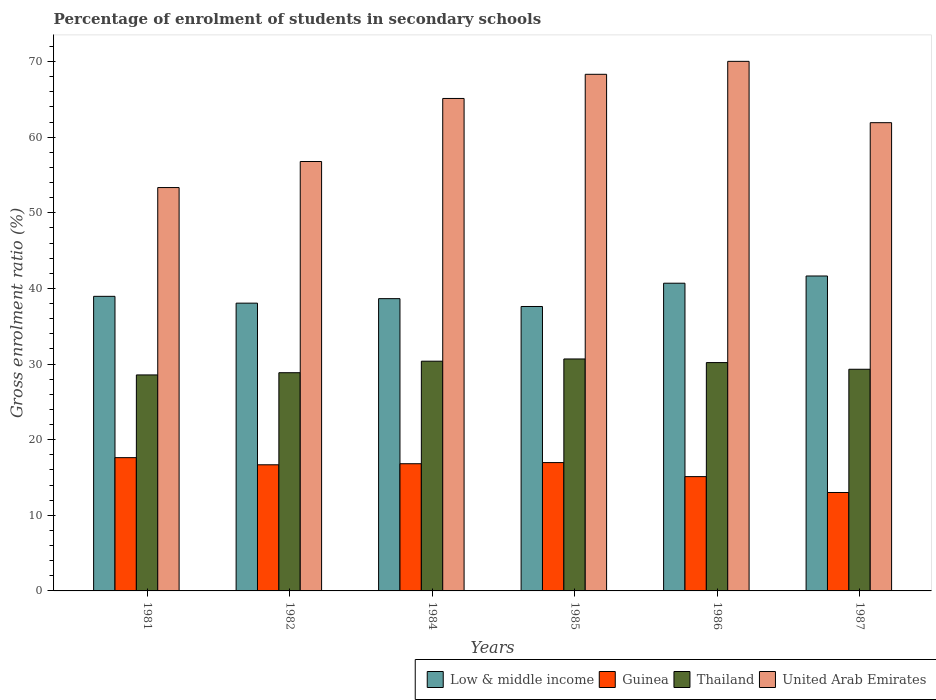How many different coloured bars are there?
Provide a succinct answer. 4. How many groups of bars are there?
Provide a succinct answer. 6. How many bars are there on the 5th tick from the right?
Your response must be concise. 4. What is the label of the 4th group of bars from the left?
Offer a very short reply. 1985. What is the percentage of students enrolled in secondary schools in United Arab Emirates in 1987?
Keep it short and to the point. 61.92. Across all years, what is the maximum percentage of students enrolled in secondary schools in United Arab Emirates?
Ensure brevity in your answer.  70.03. Across all years, what is the minimum percentage of students enrolled in secondary schools in Thailand?
Provide a short and direct response. 28.56. What is the total percentage of students enrolled in secondary schools in United Arab Emirates in the graph?
Provide a succinct answer. 375.5. What is the difference between the percentage of students enrolled in secondary schools in Guinea in 1981 and that in 1985?
Keep it short and to the point. 0.65. What is the difference between the percentage of students enrolled in secondary schools in Thailand in 1981 and the percentage of students enrolled in secondary schools in Low & middle income in 1982?
Your answer should be compact. -9.49. What is the average percentage of students enrolled in secondary schools in Thailand per year?
Your answer should be compact. 29.66. In the year 1984, what is the difference between the percentage of students enrolled in secondary schools in Low & middle income and percentage of students enrolled in secondary schools in United Arab Emirates?
Provide a short and direct response. -26.47. What is the ratio of the percentage of students enrolled in secondary schools in United Arab Emirates in 1982 to that in 1984?
Provide a short and direct response. 0.87. Is the percentage of students enrolled in secondary schools in Low & middle income in 1982 less than that in 1984?
Provide a succinct answer. Yes. Is the difference between the percentage of students enrolled in secondary schools in Low & middle income in 1981 and 1984 greater than the difference between the percentage of students enrolled in secondary schools in United Arab Emirates in 1981 and 1984?
Your answer should be compact. Yes. What is the difference between the highest and the second highest percentage of students enrolled in secondary schools in Guinea?
Provide a succinct answer. 0.65. What is the difference between the highest and the lowest percentage of students enrolled in secondary schools in Guinea?
Offer a terse response. 4.61. In how many years, is the percentage of students enrolled in secondary schools in United Arab Emirates greater than the average percentage of students enrolled in secondary schools in United Arab Emirates taken over all years?
Your answer should be very brief. 3. Is the sum of the percentage of students enrolled in secondary schools in Guinea in 1982 and 1986 greater than the maximum percentage of students enrolled in secondary schools in United Arab Emirates across all years?
Your response must be concise. No. What does the 3rd bar from the right in 1984 represents?
Your answer should be compact. Guinea. How many bars are there?
Your answer should be compact. 24. Are all the bars in the graph horizontal?
Your answer should be compact. No. How many years are there in the graph?
Provide a succinct answer. 6. Are the values on the major ticks of Y-axis written in scientific E-notation?
Ensure brevity in your answer.  No. Where does the legend appear in the graph?
Offer a terse response. Bottom right. How are the legend labels stacked?
Offer a terse response. Horizontal. What is the title of the graph?
Your answer should be very brief. Percentage of enrolment of students in secondary schools. What is the label or title of the X-axis?
Offer a terse response. Years. What is the Gross enrolment ratio (%) in Low & middle income in 1981?
Provide a succinct answer. 38.95. What is the Gross enrolment ratio (%) of Guinea in 1981?
Offer a very short reply. 17.62. What is the Gross enrolment ratio (%) of Thailand in 1981?
Your response must be concise. 28.56. What is the Gross enrolment ratio (%) in United Arab Emirates in 1981?
Make the answer very short. 53.34. What is the Gross enrolment ratio (%) in Low & middle income in 1982?
Provide a succinct answer. 38.05. What is the Gross enrolment ratio (%) of Guinea in 1982?
Give a very brief answer. 16.68. What is the Gross enrolment ratio (%) in Thailand in 1982?
Give a very brief answer. 28.85. What is the Gross enrolment ratio (%) of United Arab Emirates in 1982?
Offer a terse response. 56.78. What is the Gross enrolment ratio (%) of Low & middle income in 1984?
Offer a terse response. 38.65. What is the Gross enrolment ratio (%) of Guinea in 1984?
Make the answer very short. 16.82. What is the Gross enrolment ratio (%) in Thailand in 1984?
Your response must be concise. 30.38. What is the Gross enrolment ratio (%) in United Arab Emirates in 1984?
Provide a short and direct response. 65.12. What is the Gross enrolment ratio (%) of Low & middle income in 1985?
Ensure brevity in your answer.  37.61. What is the Gross enrolment ratio (%) of Guinea in 1985?
Your answer should be very brief. 16.97. What is the Gross enrolment ratio (%) in Thailand in 1985?
Ensure brevity in your answer.  30.67. What is the Gross enrolment ratio (%) of United Arab Emirates in 1985?
Ensure brevity in your answer.  68.31. What is the Gross enrolment ratio (%) of Low & middle income in 1986?
Make the answer very short. 40.69. What is the Gross enrolment ratio (%) in Guinea in 1986?
Offer a very short reply. 15.12. What is the Gross enrolment ratio (%) in Thailand in 1986?
Offer a very short reply. 30.19. What is the Gross enrolment ratio (%) in United Arab Emirates in 1986?
Offer a very short reply. 70.03. What is the Gross enrolment ratio (%) in Low & middle income in 1987?
Provide a short and direct response. 41.64. What is the Gross enrolment ratio (%) in Guinea in 1987?
Ensure brevity in your answer.  13.02. What is the Gross enrolment ratio (%) in Thailand in 1987?
Offer a terse response. 29.31. What is the Gross enrolment ratio (%) in United Arab Emirates in 1987?
Your response must be concise. 61.92. Across all years, what is the maximum Gross enrolment ratio (%) of Low & middle income?
Provide a succinct answer. 41.64. Across all years, what is the maximum Gross enrolment ratio (%) of Guinea?
Your answer should be very brief. 17.62. Across all years, what is the maximum Gross enrolment ratio (%) in Thailand?
Offer a very short reply. 30.67. Across all years, what is the maximum Gross enrolment ratio (%) in United Arab Emirates?
Your response must be concise. 70.03. Across all years, what is the minimum Gross enrolment ratio (%) in Low & middle income?
Ensure brevity in your answer.  37.61. Across all years, what is the minimum Gross enrolment ratio (%) in Guinea?
Give a very brief answer. 13.02. Across all years, what is the minimum Gross enrolment ratio (%) of Thailand?
Your response must be concise. 28.56. Across all years, what is the minimum Gross enrolment ratio (%) of United Arab Emirates?
Give a very brief answer. 53.34. What is the total Gross enrolment ratio (%) of Low & middle income in the graph?
Your answer should be very brief. 235.6. What is the total Gross enrolment ratio (%) in Guinea in the graph?
Ensure brevity in your answer.  96.22. What is the total Gross enrolment ratio (%) of Thailand in the graph?
Make the answer very short. 177.97. What is the total Gross enrolment ratio (%) of United Arab Emirates in the graph?
Provide a short and direct response. 375.5. What is the difference between the Gross enrolment ratio (%) in Low & middle income in 1981 and that in 1982?
Your answer should be compact. 0.9. What is the difference between the Gross enrolment ratio (%) in Guinea in 1981 and that in 1982?
Provide a short and direct response. 0.94. What is the difference between the Gross enrolment ratio (%) in Thailand in 1981 and that in 1982?
Offer a terse response. -0.29. What is the difference between the Gross enrolment ratio (%) of United Arab Emirates in 1981 and that in 1982?
Keep it short and to the point. -3.44. What is the difference between the Gross enrolment ratio (%) of Low & middle income in 1981 and that in 1984?
Make the answer very short. 0.31. What is the difference between the Gross enrolment ratio (%) of Guinea in 1981 and that in 1984?
Your response must be concise. 0.8. What is the difference between the Gross enrolment ratio (%) in Thailand in 1981 and that in 1984?
Your answer should be very brief. -1.82. What is the difference between the Gross enrolment ratio (%) in United Arab Emirates in 1981 and that in 1984?
Provide a short and direct response. -11.78. What is the difference between the Gross enrolment ratio (%) in Low & middle income in 1981 and that in 1985?
Make the answer very short. 1.34. What is the difference between the Gross enrolment ratio (%) in Guinea in 1981 and that in 1985?
Your response must be concise. 0.65. What is the difference between the Gross enrolment ratio (%) of Thailand in 1981 and that in 1985?
Provide a short and direct response. -2.11. What is the difference between the Gross enrolment ratio (%) of United Arab Emirates in 1981 and that in 1985?
Your response must be concise. -14.97. What is the difference between the Gross enrolment ratio (%) in Low & middle income in 1981 and that in 1986?
Make the answer very short. -1.74. What is the difference between the Gross enrolment ratio (%) of Guinea in 1981 and that in 1986?
Ensure brevity in your answer.  2.51. What is the difference between the Gross enrolment ratio (%) in Thailand in 1981 and that in 1986?
Give a very brief answer. -1.63. What is the difference between the Gross enrolment ratio (%) of United Arab Emirates in 1981 and that in 1986?
Your answer should be compact. -16.69. What is the difference between the Gross enrolment ratio (%) in Low & middle income in 1981 and that in 1987?
Make the answer very short. -2.69. What is the difference between the Gross enrolment ratio (%) of Guinea in 1981 and that in 1987?
Your answer should be very brief. 4.61. What is the difference between the Gross enrolment ratio (%) of Thailand in 1981 and that in 1987?
Provide a short and direct response. -0.75. What is the difference between the Gross enrolment ratio (%) of United Arab Emirates in 1981 and that in 1987?
Ensure brevity in your answer.  -8.58. What is the difference between the Gross enrolment ratio (%) of Low & middle income in 1982 and that in 1984?
Offer a very short reply. -0.6. What is the difference between the Gross enrolment ratio (%) of Guinea in 1982 and that in 1984?
Make the answer very short. -0.14. What is the difference between the Gross enrolment ratio (%) in Thailand in 1982 and that in 1984?
Provide a short and direct response. -1.52. What is the difference between the Gross enrolment ratio (%) in United Arab Emirates in 1982 and that in 1984?
Your response must be concise. -8.34. What is the difference between the Gross enrolment ratio (%) in Low & middle income in 1982 and that in 1985?
Make the answer very short. 0.44. What is the difference between the Gross enrolment ratio (%) in Guinea in 1982 and that in 1985?
Ensure brevity in your answer.  -0.29. What is the difference between the Gross enrolment ratio (%) in Thailand in 1982 and that in 1985?
Make the answer very short. -1.82. What is the difference between the Gross enrolment ratio (%) in United Arab Emirates in 1982 and that in 1985?
Your answer should be very brief. -11.53. What is the difference between the Gross enrolment ratio (%) of Low & middle income in 1982 and that in 1986?
Offer a terse response. -2.64. What is the difference between the Gross enrolment ratio (%) of Guinea in 1982 and that in 1986?
Provide a short and direct response. 1.56. What is the difference between the Gross enrolment ratio (%) in Thailand in 1982 and that in 1986?
Offer a very short reply. -1.34. What is the difference between the Gross enrolment ratio (%) of United Arab Emirates in 1982 and that in 1986?
Make the answer very short. -13.24. What is the difference between the Gross enrolment ratio (%) in Low & middle income in 1982 and that in 1987?
Provide a short and direct response. -3.59. What is the difference between the Gross enrolment ratio (%) of Guinea in 1982 and that in 1987?
Keep it short and to the point. 3.66. What is the difference between the Gross enrolment ratio (%) in Thailand in 1982 and that in 1987?
Your answer should be compact. -0.46. What is the difference between the Gross enrolment ratio (%) in United Arab Emirates in 1982 and that in 1987?
Your response must be concise. -5.13. What is the difference between the Gross enrolment ratio (%) in Low & middle income in 1984 and that in 1985?
Your answer should be compact. 1.04. What is the difference between the Gross enrolment ratio (%) in Guinea in 1984 and that in 1985?
Offer a very short reply. -0.15. What is the difference between the Gross enrolment ratio (%) of Thailand in 1984 and that in 1985?
Provide a short and direct response. -0.29. What is the difference between the Gross enrolment ratio (%) in United Arab Emirates in 1984 and that in 1985?
Your answer should be very brief. -3.19. What is the difference between the Gross enrolment ratio (%) of Low & middle income in 1984 and that in 1986?
Make the answer very short. -2.04. What is the difference between the Gross enrolment ratio (%) of Guinea in 1984 and that in 1986?
Provide a succinct answer. 1.7. What is the difference between the Gross enrolment ratio (%) in Thailand in 1984 and that in 1986?
Make the answer very short. 0.18. What is the difference between the Gross enrolment ratio (%) in United Arab Emirates in 1984 and that in 1986?
Your answer should be compact. -4.91. What is the difference between the Gross enrolment ratio (%) of Low & middle income in 1984 and that in 1987?
Offer a terse response. -3. What is the difference between the Gross enrolment ratio (%) of Guinea in 1984 and that in 1987?
Your response must be concise. 3.8. What is the difference between the Gross enrolment ratio (%) of Thailand in 1984 and that in 1987?
Provide a short and direct response. 1.07. What is the difference between the Gross enrolment ratio (%) in United Arab Emirates in 1984 and that in 1987?
Offer a very short reply. 3.2. What is the difference between the Gross enrolment ratio (%) of Low & middle income in 1985 and that in 1986?
Keep it short and to the point. -3.08. What is the difference between the Gross enrolment ratio (%) in Guinea in 1985 and that in 1986?
Provide a succinct answer. 1.85. What is the difference between the Gross enrolment ratio (%) in Thailand in 1985 and that in 1986?
Your answer should be very brief. 0.48. What is the difference between the Gross enrolment ratio (%) of United Arab Emirates in 1985 and that in 1986?
Provide a short and direct response. -1.71. What is the difference between the Gross enrolment ratio (%) of Low & middle income in 1985 and that in 1987?
Give a very brief answer. -4.03. What is the difference between the Gross enrolment ratio (%) of Guinea in 1985 and that in 1987?
Keep it short and to the point. 3.95. What is the difference between the Gross enrolment ratio (%) of Thailand in 1985 and that in 1987?
Offer a terse response. 1.36. What is the difference between the Gross enrolment ratio (%) in United Arab Emirates in 1985 and that in 1987?
Your response must be concise. 6.4. What is the difference between the Gross enrolment ratio (%) of Low & middle income in 1986 and that in 1987?
Offer a terse response. -0.95. What is the difference between the Gross enrolment ratio (%) in Guinea in 1986 and that in 1987?
Keep it short and to the point. 2.1. What is the difference between the Gross enrolment ratio (%) in Thailand in 1986 and that in 1987?
Keep it short and to the point. 0.88. What is the difference between the Gross enrolment ratio (%) of United Arab Emirates in 1986 and that in 1987?
Provide a succinct answer. 8.11. What is the difference between the Gross enrolment ratio (%) in Low & middle income in 1981 and the Gross enrolment ratio (%) in Guinea in 1982?
Make the answer very short. 22.28. What is the difference between the Gross enrolment ratio (%) in Low & middle income in 1981 and the Gross enrolment ratio (%) in Thailand in 1982?
Ensure brevity in your answer.  10.1. What is the difference between the Gross enrolment ratio (%) in Low & middle income in 1981 and the Gross enrolment ratio (%) in United Arab Emirates in 1982?
Offer a terse response. -17.83. What is the difference between the Gross enrolment ratio (%) in Guinea in 1981 and the Gross enrolment ratio (%) in Thailand in 1982?
Provide a succinct answer. -11.23. What is the difference between the Gross enrolment ratio (%) of Guinea in 1981 and the Gross enrolment ratio (%) of United Arab Emirates in 1982?
Give a very brief answer. -39.16. What is the difference between the Gross enrolment ratio (%) in Thailand in 1981 and the Gross enrolment ratio (%) in United Arab Emirates in 1982?
Your answer should be very brief. -28.22. What is the difference between the Gross enrolment ratio (%) of Low & middle income in 1981 and the Gross enrolment ratio (%) of Guinea in 1984?
Your answer should be very brief. 22.13. What is the difference between the Gross enrolment ratio (%) of Low & middle income in 1981 and the Gross enrolment ratio (%) of Thailand in 1984?
Give a very brief answer. 8.58. What is the difference between the Gross enrolment ratio (%) of Low & middle income in 1981 and the Gross enrolment ratio (%) of United Arab Emirates in 1984?
Your answer should be compact. -26.17. What is the difference between the Gross enrolment ratio (%) of Guinea in 1981 and the Gross enrolment ratio (%) of Thailand in 1984?
Give a very brief answer. -12.76. What is the difference between the Gross enrolment ratio (%) in Guinea in 1981 and the Gross enrolment ratio (%) in United Arab Emirates in 1984?
Provide a short and direct response. -47.5. What is the difference between the Gross enrolment ratio (%) in Thailand in 1981 and the Gross enrolment ratio (%) in United Arab Emirates in 1984?
Provide a short and direct response. -36.56. What is the difference between the Gross enrolment ratio (%) in Low & middle income in 1981 and the Gross enrolment ratio (%) in Guinea in 1985?
Provide a short and direct response. 21.98. What is the difference between the Gross enrolment ratio (%) in Low & middle income in 1981 and the Gross enrolment ratio (%) in Thailand in 1985?
Provide a succinct answer. 8.28. What is the difference between the Gross enrolment ratio (%) of Low & middle income in 1981 and the Gross enrolment ratio (%) of United Arab Emirates in 1985?
Keep it short and to the point. -29.36. What is the difference between the Gross enrolment ratio (%) in Guinea in 1981 and the Gross enrolment ratio (%) in Thailand in 1985?
Your response must be concise. -13.05. What is the difference between the Gross enrolment ratio (%) in Guinea in 1981 and the Gross enrolment ratio (%) in United Arab Emirates in 1985?
Provide a short and direct response. -50.69. What is the difference between the Gross enrolment ratio (%) in Thailand in 1981 and the Gross enrolment ratio (%) in United Arab Emirates in 1985?
Your answer should be compact. -39.75. What is the difference between the Gross enrolment ratio (%) of Low & middle income in 1981 and the Gross enrolment ratio (%) of Guinea in 1986?
Your answer should be very brief. 23.84. What is the difference between the Gross enrolment ratio (%) of Low & middle income in 1981 and the Gross enrolment ratio (%) of Thailand in 1986?
Provide a succinct answer. 8.76. What is the difference between the Gross enrolment ratio (%) of Low & middle income in 1981 and the Gross enrolment ratio (%) of United Arab Emirates in 1986?
Provide a succinct answer. -31.07. What is the difference between the Gross enrolment ratio (%) in Guinea in 1981 and the Gross enrolment ratio (%) in Thailand in 1986?
Give a very brief answer. -12.57. What is the difference between the Gross enrolment ratio (%) of Guinea in 1981 and the Gross enrolment ratio (%) of United Arab Emirates in 1986?
Make the answer very short. -52.4. What is the difference between the Gross enrolment ratio (%) of Thailand in 1981 and the Gross enrolment ratio (%) of United Arab Emirates in 1986?
Your response must be concise. -41.46. What is the difference between the Gross enrolment ratio (%) in Low & middle income in 1981 and the Gross enrolment ratio (%) in Guinea in 1987?
Give a very brief answer. 25.94. What is the difference between the Gross enrolment ratio (%) of Low & middle income in 1981 and the Gross enrolment ratio (%) of Thailand in 1987?
Offer a terse response. 9.64. What is the difference between the Gross enrolment ratio (%) in Low & middle income in 1981 and the Gross enrolment ratio (%) in United Arab Emirates in 1987?
Offer a terse response. -22.96. What is the difference between the Gross enrolment ratio (%) of Guinea in 1981 and the Gross enrolment ratio (%) of Thailand in 1987?
Offer a very short reply. -11.69. What is the difference between the Gross enrolment ratio (%) of Guinea in 1981 and the Gross enrolment ratio (%) of United Arab Emirates in 1987?
Make the answer very short. -44.29. What is the difference between the Gross enrolment ratio (%) in Thailand in 1981 and the Gross enrolment ratio (%) in United Arab Emirates in 1987?
Your response must be concise. -33.35. What is the difference between the Gross enrolment ratio (%) of Low & middle income in 1982 and the Gross enrolment ratio (%) of Guinea in 1984?
Your response must be concise. 21.23. What is the difference between the Gross enrolment ratio (%) of Low & middle income in 1982 and the Gross enrolment ratio (%) of Thailand in 1984?
Your response must be concise. 7.67. What is the difference between the Gross enrolment ratio (%) in Low & middle income in 1982 and the Gross enrolment ratio (%) in United Arab Emirates in 1984?
Your response must be concise. -27.07. What is the difference between the Gross enrolment ratio (%) of Guinea in 1982 and the Gross enrolment ratio (%) of Thailand in 1984?
Your answer should be very brief. -13.7. What is the difference between the Gross enrolment ratio (%) of Guinea in 1982 and the Gross enrolment ratio (%) of United Arab Emirates in 1984?
Provide a succinct answer. -48.44. What is the difference between the Gross enrolment ratio (%) in Thailand in 1982 and the Gross enrolment ratio (%) in United Arab Emirates in 1984?
Offer a very short reply. -36.27. What is the difference between the Gross enrolment ratio (%) in Low & middle income in 1982 and the Gross enrolment ratio (%) in Guinea in 1985?
Your response must be concise. 21.08. What is the difference between the Gross enrolment ratio (%) of Low & middle income in 1982 and the Gross enrolment ratio (%) of Thailand in 1985?
Provide a succinct answer. 7.38. What is the difference between the Gross enrolment ratio (%) of Low & middle income in 1982 and the Gross enrolment ratio (%) of United Arab Emirates in 1985?
Offer a terse response. -30.26. What is the difference between the Gross enrolment ratio (%) of Guinea in 1982 and the Gross enrolment ratio (%) of Thailand in 1985?
Offer a terse response. -13.99. What is the difference between the Gross enrolment ratio (%) in Guinea in 1982 and the Gross enrolment ratio (%) in United Arab Emirates in 1985?
Keep it short and to the point. -51.63. What is the difference between the Gross enrolment ratio (%) of Thailand in 1982 and the Gross enrolment ratio (%) of United Arab Emirates in 1985?
Offer a terse response. -39.46. What is the difference between the Gross enrolment ratio (%) of Low & middle income in 1982 and the Gross enrolment ratio (%) of Guinea in 1986?
Provide a succinct answer. 22.94. What is the difference between the Gross enrolment ratio (%) in Low & middle income in 1982 and the Gross enrolment ratio (%) in Thailand in 1986?
Provide a succinct answer. 7.86. What is the difference between the Gross enrolment ratio (%) of Low & middle income in 1982 and the Gross enrolment ratio (%) of United Arab Emirates in 1986?
Offer a terse response. -31.97. What is the difference between the Gross enrolment ratio (%) of Guinea in 1982 and the Gross enrolment ratio (%) of Thailand in 1986?
Make the answer very short. -13.51. What is the difference between the Gross enrolment ratio (%) in Guinea in 1982 and the Gross enrolment ratio (%) in United Arab Emirates in 1986?
Offer a terse response. -53.35. What is the difference between the Gross enrolment ratio (%) in Thailand in 1982 and the Gross enrolment ratio (%) in United Arab Emirates in 1986?
Your answer should be compact. -41.17. What is the difference between the Gross enrolment ratio (%) of Low & middle income in 1982 and the Gross enrolment ratio (%) of Guinea in 1987?
Make the answer very short. 25.04. What is the difference between the Gross enrolment ratio (%) in Low & middle income in 1982 and the Gross enrolment ratio (%) in Thailand in 1987?
Keep it short and to the point. 8.74. What is the difference between the Gross enrolment ratio (%) in Low & middle income in 1982 and the Gross enrolment ratio (%) in United Arab Emirates in 1987?
Make the answer very short. -23.86. What is the difference between the Gross enrolment ratio (%) in Guinea in 1982 and the Gross enrolment ratio (%) in Thailand in 1987?
Provide a succinct answer. -12.63. What is the difference between the Gross enrolment ratio (%) of Guinea in 1982 and the Gross enrolment ratio (%) of United Arab Emirates in 1987?
Keep it short and to the point. -45.24. What is the difference between the Gross enrolment ratio (%) in Thailand in 1982 and the Gross enrolment ratio (%) in United Arab Emirates in 1987?
Provide a succinct answer. -33.06. What is the difference between the Gross enrolment ratio (%) of Low & middle income in 1984 and the Gross enrolment ratio (%) of Guinea in 1985?
Keep it short and to the point. 21.68. What is the difference between the Gross enrolment ratio (%) of Low & middle income in 1984 and the Gross enrolment ratio (%) of Thailand in 1985?
Offer a terse response. 7.98. What is the difference between the Gross enrolment ratio (%) of Low & middle income in 1984 and the Gross enrolment ratio (%) of United Arab Emirates in 1985?
Your response must be concise. -29.67. What is the difference between the Gross enrolment ratio (%) of Guinea in 1984 and the Gross enrolment ratio (%) of Thailand in 1985?
Ensure brevity in your answer.  -13.85. What is the difference between the Gross enrolment ratio (%) in Guinea in 1984 and the Gross enrolment ratio (%) in United Arab Emirates in 1985?
Keep it short and to the point. -51.49. What is the difference between the Gross enrolment ratio (%) in Thailand in 1984 and the Gross enrolment ratio (%) in United Arab Emirates in 1985?
Provide a succinct answer. -37.94. What is the difference between the Gross enrolment ratio (%) of Low & middle income in 1984 and the Gross enrolment ratio (%) of Guinea in 1986?
Ensure brevity in your answer.  23.53. What is the difference between the Gross enrolment ratio (%) of Low & middle income in 1984 and the Gross enrolment ratio (%) of Thailand in 1986?
Ensure brevity in your answer.  8.45. What is the difference between the Gross enrolment ratio (%) of Low & middle income in 1984 and the Gross enrolment ratio (%) of United Arab Emirates in 1986?
Your response must be concise. -31.38. What is the difference between the Gross enrolment ratio (%) of Guinea in 1984 and the Gross enrolment ratio (%) of Thailand in 1986?
Ensure brevity in your answer.  -13.37. What is the difference between the Gross enrolment ratio (%) of Guinea in 1984 and the Gross enrolment ratio (%) of United Arab Emirates in 1986?
Provide a short and direct response. -53.21. What is the difference between the Gross enrolment ratio (%) in Thailand in 1984 and the Gross enrolment ratio (%) in United Arab Emirates in 1986?
Your response must be concise. -39.65. What is the difference between the Gross enrolment ratio (%) in Low & middle income in 1984 and the Gross enrolment ratio (%) in Guinea in 1987?
Offer a very short reply. 25.63. What is the difference between the Gross enrolment ratio (%) of Low & middle income in 1984 and the Gross enrolment ratio (%) of Thailand in 1987?
Your answer should be compact. 9.34. What is the difference between the Gross enrolment ratio (%) in Low & middle income in 1984 and the Gross enrolment ratio (%) in United Arab Emirates in 1987?
Your answer should be very brief. -23.27. What is the difference between the Gross enrolment ratio (%) of Guinea in 1984 and the Gross enrolment ratio (%) of Thailand in 1987?
Offer a very short reply. -12.49. What is the difference between the Gross enrolment ratio (%) in Guinea in 1984 and the Gross enrolment ratio (%) in United Arab Emirates in 1987?
Provide a succinct answer. -45.1. What is the difference between the Gross enrolment ratio (%) in Thailand in 1984 and the Gross enrolment ratio (%) in United Arab Emirates in 1987?
Ensure brevity in your answer.  -31.54. What is the difference between the Gross enrolment ratio (%) in Low & middle income in 1985 and the Gross enrolment ratio (%) in Guinea in 1986?
Keep it short and to the point. 22.5. What is the difference between the Gross enrolment ratio (%) in Low & middle income in 1985 and the Gross enrolment ratio (%) in Thailand in 1986?
Make the answer very short. 7.42. What is the difference between the Gross enrolment ratio (%) in Low & middle income in 1985 and the Gross enrolment ratio (%) in United Arab Emirates in 1986?
Provide a short and direct response. -32.41. What is the difference between the Gross enrolment ratio (%) of Guinea in 1985 and the Gross enrolment ratio (%) of Thailand in 1986?
Ensure brevity in your answer.  -13.22. What is the difference between the Gross enrolment ratio (%) in Guinea in 1985 and the Gross enrolment ratio (%) in United Arab Emirates in 1986?
Offer a very short reply. -53.06. What is the difference between the Gross enrolment ratio (%) in Thailand in 1985 and the Gross enrolment ratio (%) in United Arab Emirates in 1986?
Keep it short and to the point. -39.35. What is the difference between the Gross enrolment ratio (%) in Low & middle income in 1985 and the Gross enrolment ratio (%) in Guinea in 1987?
Offer a very short reply. 24.6. What is the difference between the Gross enrolment ratio (%) of Low & middle income in 1985 and the Gross enrolment ratio (%) of Thailand in 1987?
Your answer should be very brief. 8.3. What is the difference between the Gross enrolment ratio (%) in Low & middle income in 1985 and the Gross enrolment ratio (%) in United Arab Emirates in 1987?
Give a very brief answer. -24.3. What is the difference between the Gross enrolment ratio (%) in Guinea in 1985 and the Gross enrolment ratio (%) in Thailand in 1987?
Your answer should be very brief. -12.34. What is the difference between the Gross enrolment ratio (%) of Guinea in 1985 and the Gross enrolment ratio (%) of United Arab Emirates in 1987?
Ensure brevity in your answer.  -44.95. What is the difference between the Gross enrolment ratio (%) of Thailand in 1985 and the Gross enrolment ratio (%) of United Arab Emirates in 1987?
Give a very brief answer. -31.24. What is the difference between the Gross enrolment ratio (%) in Low & middle income in 1986 and the Gross enrolment ratio (%) in Guinea in 1987?
Provide a short and direct response. 27.67. What is the difference between the Gross enrolment ratio (%) in Low & middle income in 1986 and the Gross enrolment ratio (%) in Thailand in 1987?
Offer a terse response. 11.38. What is the difference between the Gross enrolment ratio (%) of Low & middle income in 1986 and the Gross enrolment ratio (%) of United Arab Emirates in 1987?
Your answer should be compact. -21.23. What is the difference between the Gross enrolment ratio (%) of Guinea in 1986 and the Gross enrolment ratio (%) of Thailand in 1987?
Provide a short and direct response. -14.2. What is the difference between the Gross enrolment ratio (%) of Guinea in 1986 and the Gross enrolment ratio (%) of United Arab Emirates in 1987?
Your answer should be very brief. -46.8. What is the difference between the Gross enrolment ratio (%) of Thailand in 1986 and the Gross enrolment ratio (%) of United Arab Emirates in 1987?
Your response must be concise. -31.72. What is the average Gross enrolment ratio (%) in Low & middle income per year?
Your answer should be very brief. 39.27. What is the average Gross enrolment ratio (%) in Guinea per year?
Make the answer very short. 16.04. What is the average Gross enrolment ratio (%) of Thailand per year?
Make the answer very short. 29.66. What is the average Gross enrolment ratio (%) in United Arab Emirates per year?
Your answer should be very brief. 62.58. In the year 1981, what is the difference between the Gross enrolment ratio (%) in Low & middle income and Gross enrolment ratio (%) in Guinea?
Provide a short and direct response. 21.33. In the year 1981, what is the difference between the Gross enrolment ratio (%) in Low & middle income and Gross enrolment ratio (%) in Thailand?
Make the answer very short. 10.39. In the year 1981, what is the difference between the Gross enrolment ratio (%) in Low & middle income and Gross enrolment ratio (%) in United Arab Emirates?
Ensure brevity in your answer.  -14.39. In the year 1981, what is the difference between the Gross enrolment ratio (%) of Guinea and Gross enrolment ratio (%) of Thailand?
Keep it short and to the point. -10.94. In the year 1981, what is the difference between the Gross enrolment ratio (%) of Guinea and Gross enrolment ratio (%) of United Arab Emirates?
Offer a terse response. -35.72. In the year 1981, what is the difference between the Gross enrolment ratio (%) of Thailand and Gross enrolment ratio (%) of United Arab Emirates?
Keep it short and to the point. -24.78. In the year 1982, what is the difference between the Gross enrolment ratio (%) in Low & middle income and Gross enrolment ratio (%) in Guinea?
Provide a succinct answer. 21.37. In the year 1982, what is the difference between the Gross enrolment ratio (%) in Low & middle income and Gross enrolment ratio (%) in Thailand?
Provide a short and direct response. 9.2. In the year 1982, what is the difference between the Gross enrolment ratio (%) of Low & middle income and Gross enrolment ratio (%) of United Arab Emirates?
Give a very brief answer. -18.73. In the year 1982, what is the difference between the Gross enrolment ratio (%) in Guinea and Gross enrolment ratio (%) in Thailand?
Keep it short and to the point. -12.18. In the year 1982, what is the difference between the Gross enrolment ratio (%) in Guinea and Gross enrolment ratio (%) in United Arab Emirates?
Keep it short and to the point. -40.1. In the year 1982, what is the difference between the Gross enrolment ratio (%) of Thailand and Gross enrolment ratio (%) of United Arab Emirates?
Your answer should be very brief. -27.93. In the year 1984, what is the difference between the Gross enrolment ratio (%) of Low & middle income and Gross enrolment ratio (%) of Guinea?
Provide a short and direct response. 21.83. In the year 1984, what is the difference between the Gross enrolment ratio (%) in Low & middle income and Gross enrolment ratio (%) in Thailand?
Your response must be concise. 8.27. In the year 1984, what is the difference between the Gross enrolment ratio (%) in Low & middle income and Gross enrolment ratio (%) in United Arab Emirates?
Ensure brevity in your answer.  -26.47. In the year 1984, what is the difference between the Gross enrolment ratio (%) in Guinea and Gross enrolment ratio (%) in Thailand?
Offer a terse response. -13.56. In the year 1984, what is the difference between the Gross enrolment ratio (%) of Guinea and Gross enrolment ratio (%) of United Arab Emirates?
Provide a short and direct response. -48.3. In the year 1984, what is the difference between the Gross enrolment ratio (%) in Thailand and Gross enrolment ratio (%) in United Arab Emirates?
Give a very brief answer. -34.74. In the year 1985, what is the difference between the Gross enrolment ratio (%) of Low & middle income and Gross enrolment ratio (%) of Guinea?
Your response must be concise. 20.64. In the year 1985, what is the difference between the Gross enrolment ratio (%) in Low & middle income and Gross enrolment ratio (%) in Thailand?
Your response must be concise. 6.94. In the year 1985, what is the difference between the Gross enrolment ratio (%) of Low & middle income and Gross enrolment ratio (%) of United Arab Emirates?
Your answer should be very brief. -30.7. In the year 1985, what is the difference between the Gross enrolment ratio (%) of Guinea and Gross enrolment ratio (%) of Thailand?
Offer a very short reply. -13.7. In the year 1985, what is the difference between the Gross enrolment ratio (%) in Guinea and Gross enrolment ratio (%) in United Arab Emirates?
Offer a very short reply. -51.34. In the year 1985, what is the difference between the Gross enrolment ratio (%) of Thailand and Gross enrolment ratio (%) of United Arab Emirates?
Make the answer very short. -37.64. In the year 1986, what is the difference between the Gross enrolment ratio (%) of Low & middle income and Gross enrolment ratio (%) of Guinea?
Your response must be concise. 25.57. In the year 1986, what is the difference between the Gross enrolment ratio (%) of Low & middle income and Gross enrolment ratio (%) of Thailand?
Your answer should be very brief. 10.5. In the year 1986, what is the difference between the Gross enrolment ratio (%) in Low & middle income and Gross enrolment ratio (%) in United Arab Emirates?
Ensure brevity in your answer.  -29.34. In the year 1986, what is the difference between the Gross enrolment ratio (%) of Guinea and Gross enrolment ratio (%) of Thailand?
Your answer should be very brief. -15.08. In the year 1986, what is the difference between the Gross enrolment ratio (%) of Guinea and Gross enrolment ratio (%) of United Arab Emirates?
Offer a very short reply. -54.91. In the year 1986, what is the difference between the Gross enrolment ratio (%) in Thailand and Gross enrolment ratio (%) in United Arab Emirates?
Keep it short and to the point. -39.83. In the year 1987, what is the difference between the Gross enrolment ratio (%) in Low & middle income and Gross enrolment ratio (%) in Guinea?
Your answer should be very brief. 28.63. In the year 1987, what is the difference between the Gross enrolment ratio (%) in Low & middle income and Gross enrolment ratio (%) in Thailand?
Your response must be concise. 12.33. In the year 1987, what is the difference between the Gross enrolment ratio (%) in Low & middle income and Gross enrolment ratio (%) in United Arab Emirates?
Make the answer very short. -20.27. In the year 1987, what is the difference between the Gross enrolment ratio (%) in Guinea and Gross enrolment ratio (%) in Thailand?
Provide a short and direct response. -16.29. In the year 1987, what is the difference between the Gross enrolment ratio (%) in Guinea and Gross enrolment ratio (%) in United Arab Emirates?
Ensure brevity in your answer.  -48.9. In the year 1987, what is the difference between the Gross enrolment ratio (%) of Thailand and Gross enrolment ratio (%) of United Arab Emirates?
Ensure brevity in your answer.  -32.61. What is the ratio of the Gross enrolment ratio (%) in Low & middle income in 1981 to that in 1982?
Your answer should be compact. 1.02. What is the ratio of the Gross enrolment ratio (%) in Guinea in 1981 to that in 1982?
Provide a short and direct response. 1.06. What is the ratio of the Gross enrolment ratio (%) in Thailand in 1981 to that in 1982?
Give a very brief answer. 0.99. What is the ratio of the Gross enrolment ratio (%) in United Arab Emirates in 1981 to that in 1982?
Give a very brief answer. 0.94. What is the ratio of the Gross enrolment ratio (%) in Low & middle income in 1981 to that in 1984?
Provide a succinct answer. 1.01. What is the ratio of the Gross enrolment ratio (%) in Guinea in 1981 to that in 1984?
Provide a short and direct response. 1.05. What is the ratio of the Gross enrolment ratio (%) in Thailand in 1981 to that in 1984?
Your answer should be very brief. 0.94. What is the ratio of the Gross enrolment ratio (%) in United Arab Emirates in 1981 to that in 1984?
Your answer should be compact. 0.82. What is the ratio of the Gross enrolment ratio (%) in Low & middle income in 1981 to that in 1985?
Ensure brevity in your answer.  1.04. What is the ratio of the Gross enrolment ratio (%) in Thailand in 1981 to that in 1985?
Offer a terse response. 0.93. What is the ratio of the Gross enrolment ratio (%) of United Arab Emirates in 1981 to that in 1985?
Make the answer very short. 0.78. What is the ratio of the Gross enrolment ratio (%) in Low & middle income in 1981 to that in 1986?
Ensure brevity in your answer.  0.96. What is the ratio of the Gross enrolment ratio (%) of Guinea in 1981 to that in 1986?
Offer a very short reply. 1.17. What is the ratio of the Gross enrolment ratio (%) in Thailand in 1981 to that in 1986?
Your response must be concise. 0.95. What is the ratio of the Gross enrolment ratio (%) in United Arab Emirates in 1981 to that in 1986?
Your response must be concise. 0.76. What is the ratio of the Gross enrolment ratio (%) of Low & middle income in 1981 to that in 1987?
Your response must be concise. 0.94. What is the ratio of the Gross enrolment ratio (%) in Guinea in 1981 to that in 1987?
Offer a terse response. 1.35. What is the ratio of the Gross enrolment ratio (%) in Thailand in 1981 to that in 1987?
Offer a very short reply. 0.97. What is the ratio of the Gross enrolment ratio (%) in United Arab Emirates in 1981 to that in 1987?
Your response must be concise. 0.86. What is the ratio of the Gross enrolment ratio (%) in Low & middle income in 1982 to that in 1984?
Offer a very short reply. 0.98. What is the ratio of the Gross enrolment ratio (%) of Guinea in 1982 to that in 1984?
Your answer should be compact. 0.99. What is the ratio of the Gross enrolment ratio (%) of Thailand in 1982 to that in 1984?
Your answer should be compact. 0.95. What is the ratio of the Gross enrolment ratio (%) of United Arab Emirates in 1982 to that in 1984?
Keep it short and to the point. 0.87. What is the ratio of the Gross enrolment ratio (%) in Low & middle income in 1982 to that in 1985?
Keep it short and to the point. 1.01. What is the ratio of the Gross enrolment ratio (%) of Guinea in 1982 to that in 1985?
Provide a short and direct response. 0.98. What is the ratio of the Gross enrolment ratio (%) of Thailand in 1982 to that in 1985?
Offer a terse response. 0.94. What is the ratio of the Gross enrolment ratio (%) of United Arab Emirates in 1982 to that in 1985?
Make the answer very short. 0.83. What is the ratio of the Gross enrolment ratio (%) of Low & middle income in 1982 to that in 1986?
Provide a succinct answer. 0.94. What is the ratio of the Gross enrolment ratio (%) in Guinea in 1982 to that in 1986?
Your response must be concise. 1.1. What is the ratio of the Gross enrolment ratio (%) of Thailand in 1982 to that in 1986?
Give a very brief answer. 0.96. What is the ratio of the Gross enrolment ratio (%) of United Arab Emirates in 1982 to that in 1986?
Ensure brevity in your answer.  0.81. What is the ratio of the Gross enrolment ratio (%) of Low & middle income in 1982 to that in 1987?
Provide a short and direct response. 0.91. What is the ratio of the Gross enrolment ratio (%) of Guinea in 1982 to that in 1987?
Ensure brevity in your answer.  1.28. What is the ratio of the Gross enrolment ratio (%) in Thailand in 1982 to that in 1987?
Provide a short and direct response. 0.98. What is the ratio of the Gross enrolment ratio (%) in United Arab Emirates in 1982 to that in 1987?
Provide a short and direct response. 0.92. What is the ratio of the Gross enrolment ratio (%) in Low & middle income in 1984 to that in 1985?
Ensure brevity in your answer.  1.03. What is the ratio of the Gross enrolment ratio (%) in Thailand in 1984 to that in 1985?
Your answer should be compact. 0.99. What is the ratio of the Gross enrolment ratio (%) of United Arab Emirates in 1984 to that in 1985?
Your answer should be compact. 0.95. What is the ratio of the Gross enrolment ratio (%) in Low & middle income in 1984 to that in 1986?
Make the answer very short. 0.95. What is the ratio of the Gross enrolment ratio (%) in Guinea in 1984 to that in 1986?
Keep it short and to the point. 1.11. What is the ratio of the Gross enrolment ratio (%) of Thailand in 1984 to that in 1986?
Offer a very short reply. 1.01. What is the ratio of the Gross enrolment ratio (%) in United Arab Emirates in 1984 to that in 1986?
Keep it short and to the point. 0.93. What is the ratio of the Gross enrolment ratio (%) in Low & middle income in 1984 to that in 1987?
Provide a succinct answer. 0.93. What is the ratio of the Gross enrolment ratio (%) of Guinea in 1984 to that in 1987?
Provide a short and direct response. 1.29. What is the ratio of the Gross enrolment ratio (%) of Thailand in 1984 to that in 1987?
Offer a very short reply. 1.04. What is the ratio of the Gross enrolment ratio (%) in United Arab Emirates in 1984 to that in 1987?
Your answer should be very brief. 1.05. What is the ratio of the Gross enrolment ratio (%) of Low & middle income in 1985 to that in 1986?
Offer a terse response. 0.92. What is the ratio of the Gross enrolment ratio (%) of Guinea in 1985 to that in 1986?
Provide a succinct answer. 1.12. What is the ratio of the Gross enrolment ratio (%) of Thailand in 1985 to that in 1986?
Provide a succinct answer. 1.02. What is the ratio of the Gross enrolment ratio (%) in United Arab Emirates in 1985 to that in 1986?
Your answer should be very brief. 0.98. What is the ratio of the Gross enrolment ratio (%) in Low & middle income in 1985 to that in 1987?
Keep it short and to the point. 0.9. What is the ratio of the Gross enrolment ratio (%) in Guinea in 1985 to that in 1987?
Your answer should be very brief. 1.3. What is the ratio of the Gross enrolment ratio (%) in Thailand in 1985 to that in 1987?
Your answer should be very brief. 1.05. What is the ratio of the Gross enrolment ratio (%) in United Arab Emirates in 1985 to that in 1987?
Your answer should be very brief. 1.1. What is the ratio of the Gross enrolment ratio (%) of Low & middle income in 1986 to that in 1987?
Your answer should be very brief. 0.98. What is the ratio of the Gross enrolment ratio (%) of Guinea in 1986 to that in 1987?
Provide a succinct answer. 1.16. What is the ratio of the Gross enrolment ratio (%) of Thailand in 1986 to that in 1987?
Your response must be concise. 1.03. What is the ratio of the Gross enrolment ratio (%) of United Arab Emirates in 1986 to that in 1987?
Offer a terse response. 1.13. What is the difference between the highest and the second highest Gross enrolment ratio (%) of Low & middle income?
Your answer should be very brief. 0.95. What is the difference between the highest and the second highest Gross enrolment ratio (%) of Guinea?
Your answer should be compact. 0.65. What is the difference between the highest and the second highest Gross enrolment ratio (%) in Thailand?
Your answer should be very brief. 0.29. What is the difference between the highest and the second highest Gross enrolment ratio (%) in United Arab Emirates?
Your answer should be compact. 1.71. What is the difference between the highest and the lowest Gross enrolment ratio (%) of Low & middle income?
Offer a terse response. 4.03. What is the difference between the highest and the lowest Gross enrolment ratio (%) in Guinea?
Offer a terse response. 4.61. What is the difference between the highest and the lowest Gross enrolment ratio (%) of Thailand?
Provide a succinct answer. 2.11. What is the difference between the highest and the lowest Gross enrolment ratio (%) of United Arab Emirates?
Make the answer very short. 16.69. 